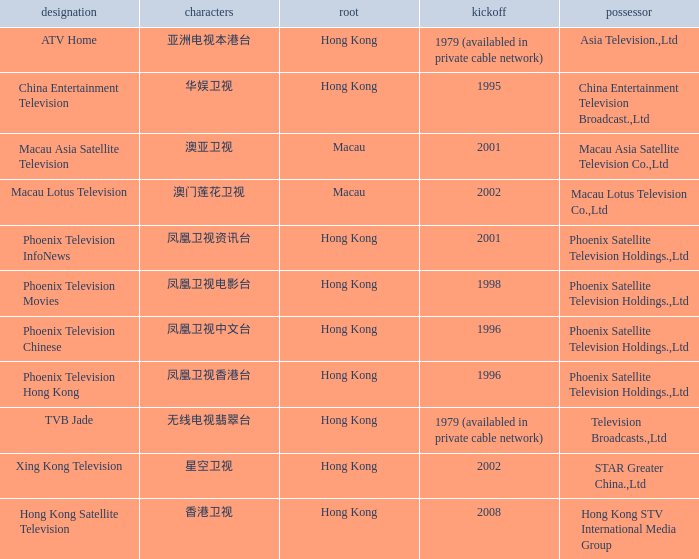What is the Hanzi of Phoenix Television Chinese that launched in 1996? 凤凰卫视中文台. 